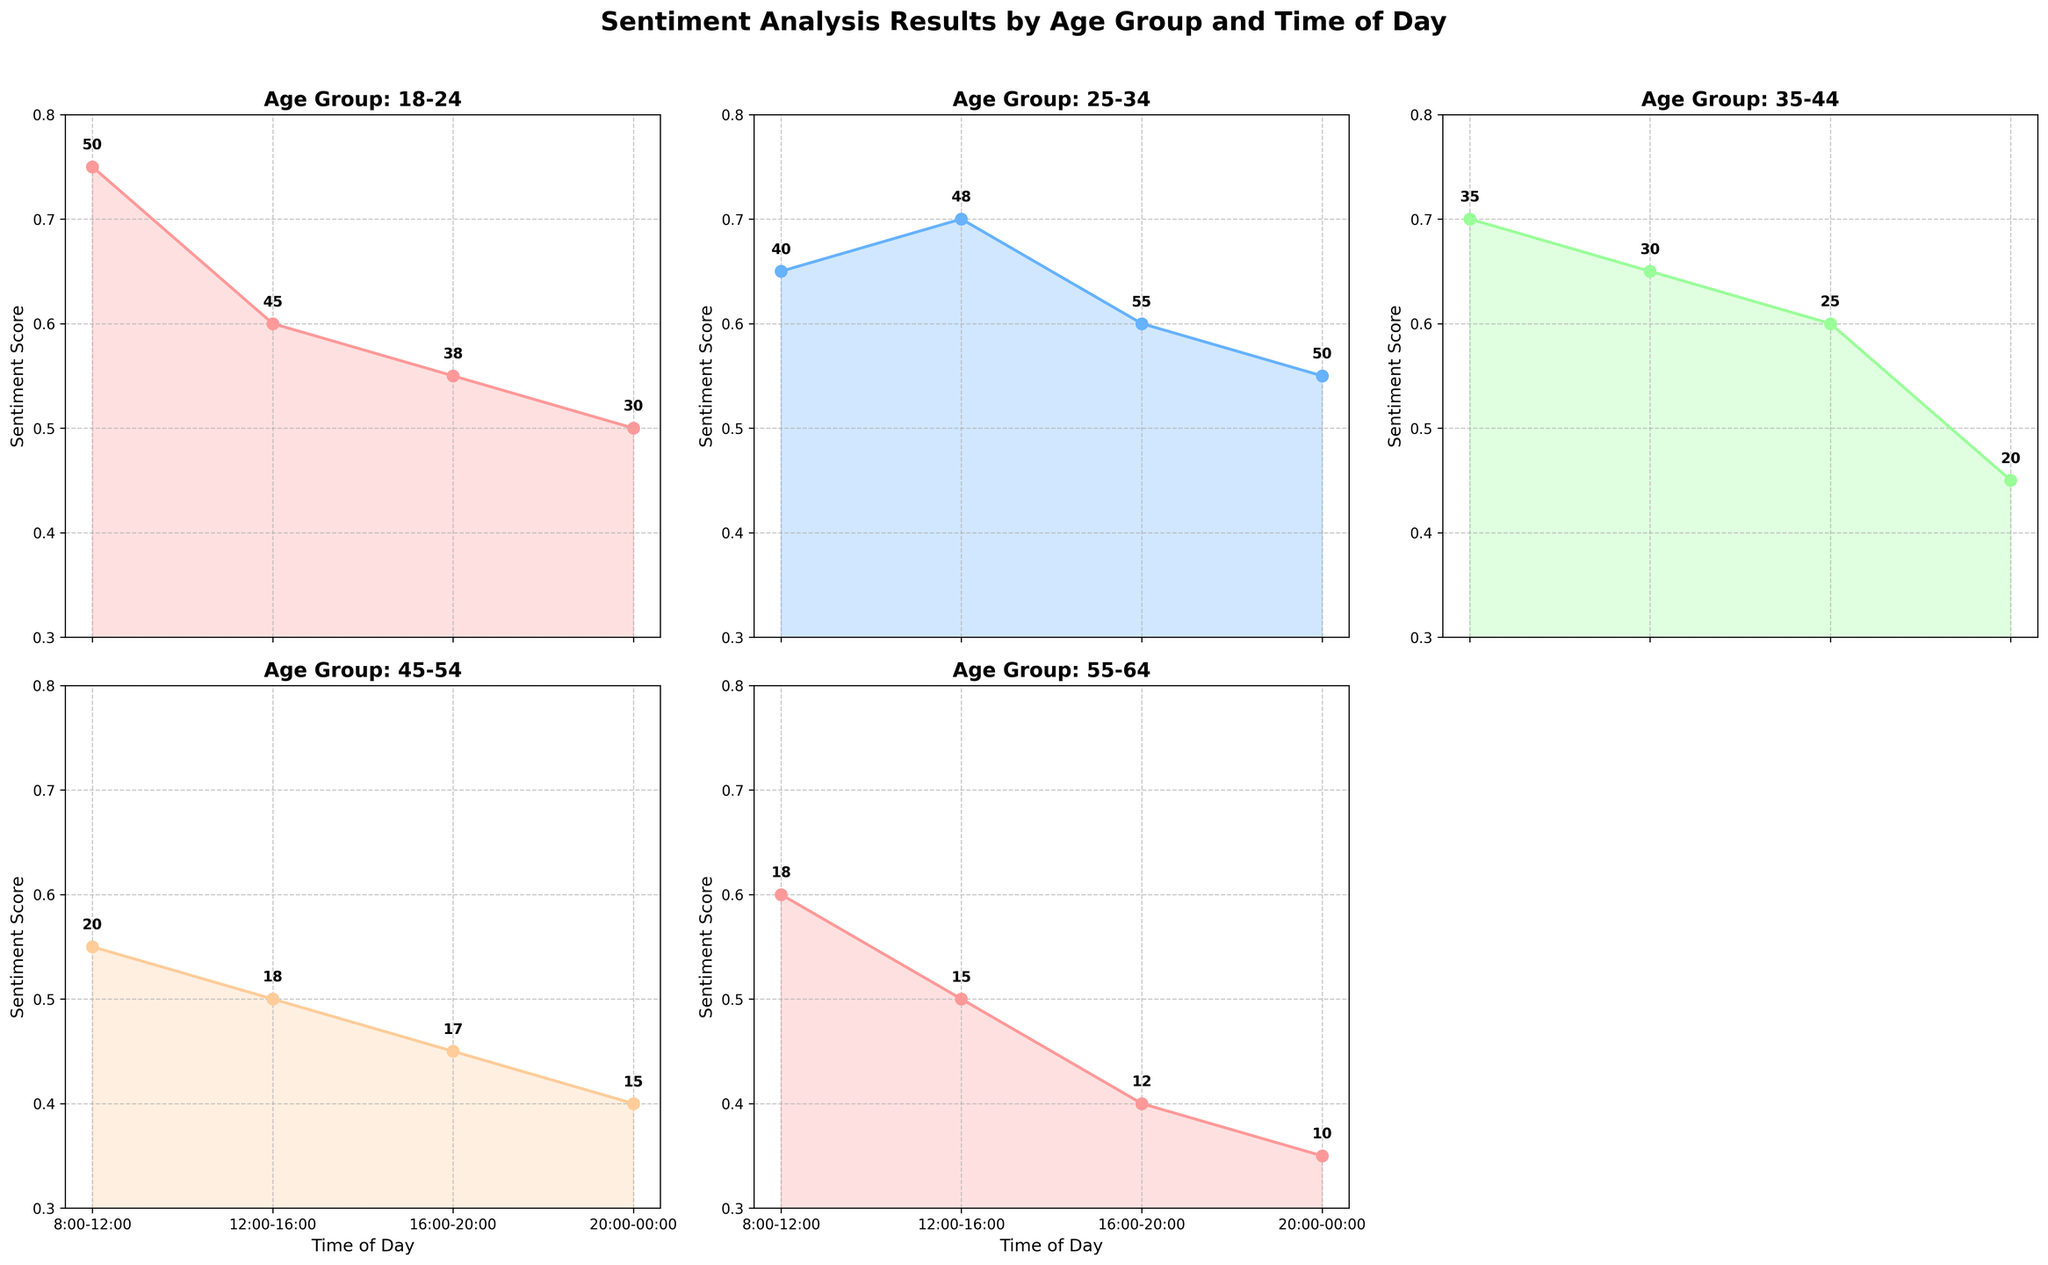What is the title of the figure? The title of the figure can be found at the top of the chart and indicates the overall subject of the data visualized in the subplots. In this case, the title is displayed above all subplots and reads "Sentiment Analysis Results by Age Group and Time of Day".
Answer: Sentiment Analysis Results by Age Group and Time of Day How many subplots are present in the figure? By counting the separate sections (boxes) in which the data is plotted, it is evident that the figure contains five subplots.
Answer: Five Which age group has the highest sentiment score in the morning (8:00-12:00)? Look for the subplot titled "Age Group: 18-24", check the area chart for the sentiment score in the "Morning" time period, which is depicted on the x-axis between 8:00 and 12:00. This age group shows a sentiment score of 0.75.
Answer: 18-24 What is the difference in sentiment score between the Afternoon and Night time periods for the 35-44 age group? Locate the subplot for "Age Group: 35-44" and find the sentiment scores for "Afternoon" and "Night" from the plotted lines or areas. The afternoon score is 0.65 and the night score is 0.45. Subtract the Night score from the Afternoon score to get the difference: 0.65 - 0.45.
Answer: 0.20 Which time of day has the lowest interaction count for the age group 45-54? Check the subplot for "Age Group: 45-54" and look at the interaction counts annotated near the data points for each time of day. The lowest interaction count is visible as 15, which corresponds to the "Night" time period.
Answer: Night For age group 55-64, what is the average sentiment score across all time periods? Look at the subplot for "Age Group: 55-64" and write down the sentiment scores for all the time periods: Morning (0.60), Afternoon (0.50), Evening (0.40), Night (0.35). The average is calculated by summing these scores and dividing by the number of time periods: (0.60 + 0.50 + 0.40 + 0.35) / 4.
Answer: 0.4625 Does the sentiment score for the 25-34 age group increase or decrease from Morning to Afternoon? Check the subplot for "Age Group: 25-34" and observe the sentiment scores for "Morning" and "Afternoon". The scores are 0.65 for Morning and 0.70 for Afternoon, indicating an increase.
Answer: Increase Which age group shows the most significant drop in sentiment score from Evening to Night? Examine each subplot, compare the sentiment scores for "Evening" and "Night". Calculating the differences: 18-24 (0.55-0.50=0.05), 25-34 (0.60-0.55=0.05), 35-44 (0.60-0.45=0.15), 45-54 (0.45-0.40=0.05), and 55-64 (0.40-0.35=0.05). The age group 35-44 has the highest difference of 0.15.
Answer: 35-44 What is the color used to represent the 25-34 age group? By observing the figure, the color corresponding to the 25-34 age group in its subplot is the second one in the palette. This is visible as a shade of blue.
Answer: Blue 